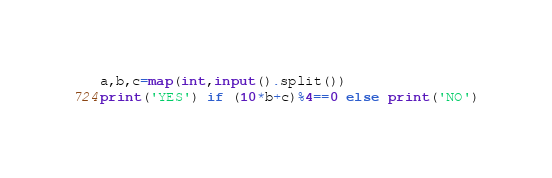<code> <loc_0><loc_0><loc_500><loc_500><_Python_>a,b,c=map(int,input().split())
print('YES') if (10*b+c)%4==0 else print('NO')</code> 